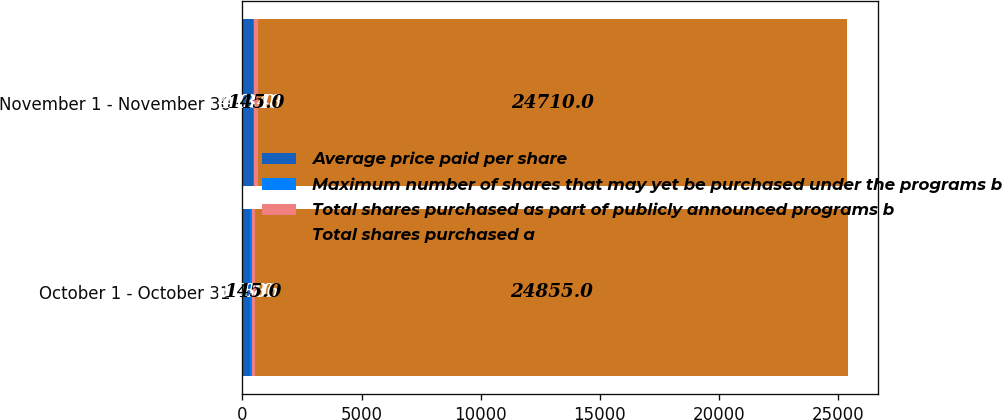Convert chart to OTSL. <chart><loc_0><loc_0><loc_500><loc_500><stacked_bar_chart><ecel><fcel>October 1 - October 31<fcel>November 1 - November 30<nl><fcel>Average price paid per share<fcel>318<fcel>433<nl><fcel>Maximum number of shares that may yet be purchased under the programs b<fcel>70.86<fcel>70.48<nl><fcel>Total shares purchased as part of publicly announced programs b<fcel>145<fcel>145<nl><fcel>Total shares purchased a<fcel>24855<fcel>24710<nl></chart> 